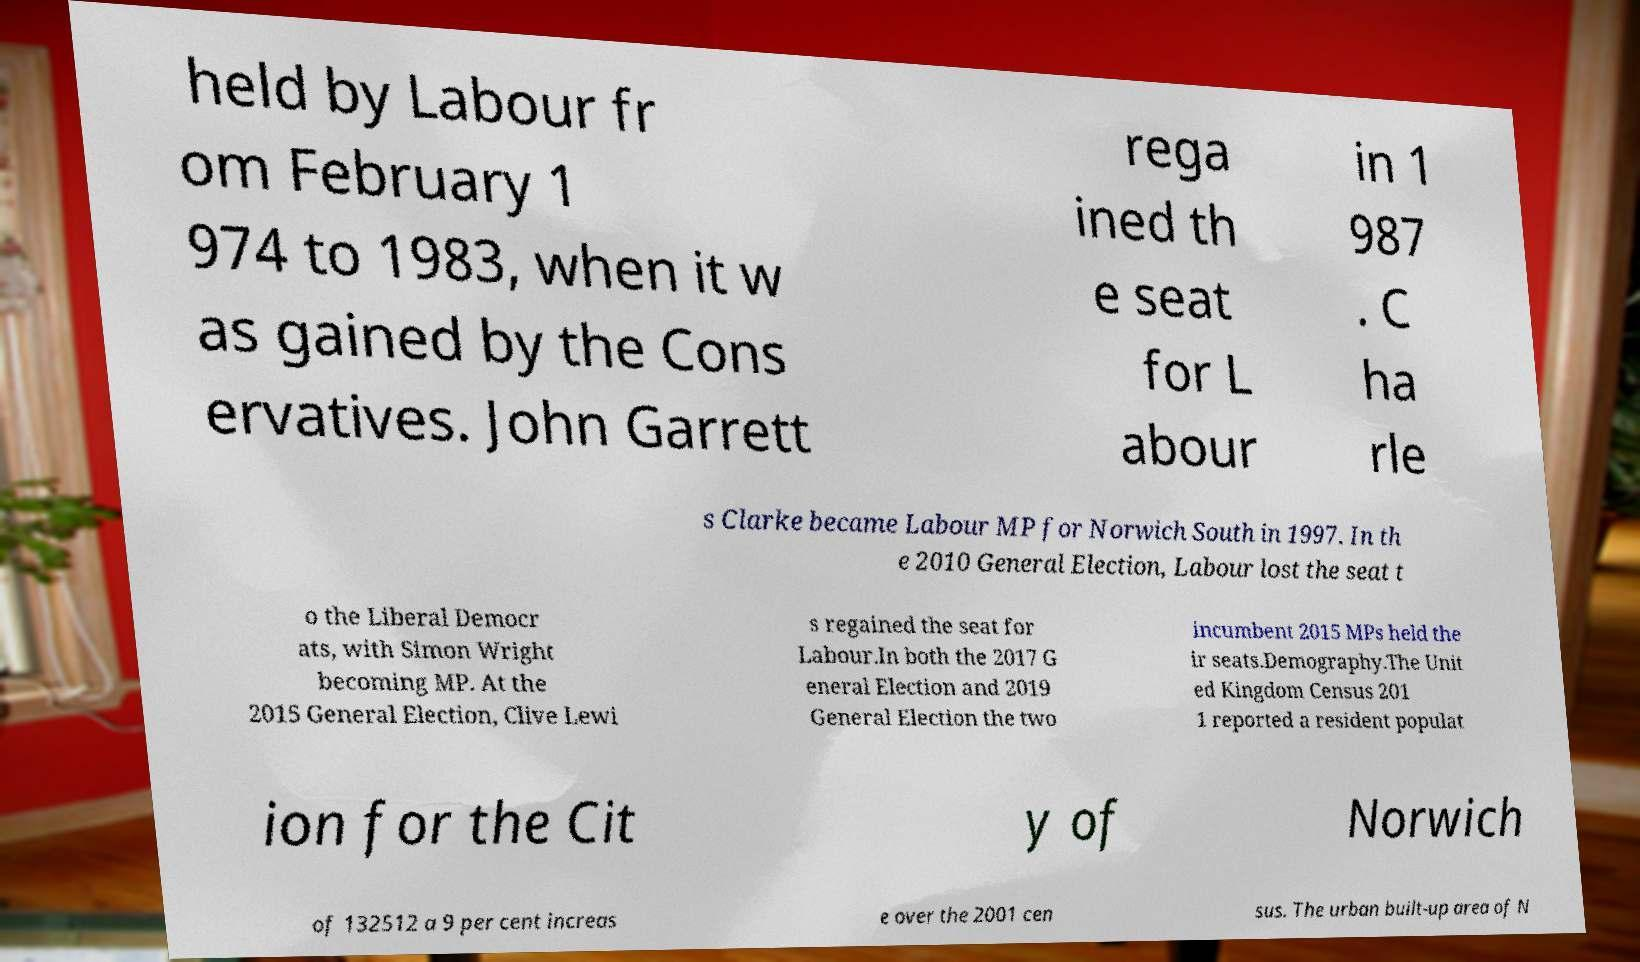What messages or text are displayed in this image? I need them in a readable, typed format. held by Labour fr om February 1 974 to 1983, when it w as gained by the Cons ervatives. John Garrett rega ined th e seat for L abour in 1 987 . C ha rle s Clarke became Labour MP for Norwich South in 1997. In th e 2010 General Election, Labour lost the seat t o the Liberal Democr ats, with Simon Wright becoming MP. At the 2015 General Election, Clive Lewi s regained the seat for Labour.In both the 2017 G eneral Election and 2019 General Election the two incumbent 2015 MPs held the ir seats.Demography.The Unit ed Kingdom Census 201 1 reported a resident populat ion for the Cit y of Norwich of 132512 a 9 per cent increas e over the 2001 cen sus. The urban built-up area of N 